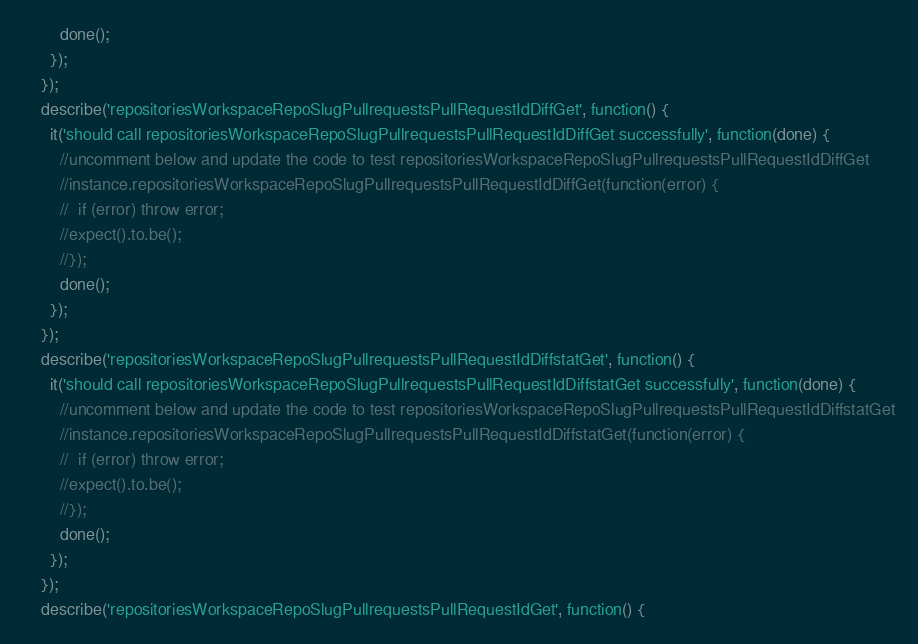<code> <loc_0><loc_0><loc_500><loc_500><_JavaScript_>        done();
      });
    });
    describe('repositoriesWorkspaceRepoSlugPullrequestsPullRequestIdDiffGet', function() {
      it('should call repositoriesWorkspaceRepoSlugPullrequestsPullRequestIdDiffGet successfully', function(done) {
        //uncomment below and update the code to test repositoriesWorkspaceRepoSlugPullrequestsPullRequestIdDiffGet
        //instance.repositoriesWorkspaceRepoSlugPullrequestsPullRequestIdDiffGet(function(error) {
        //  if (error) throw error;
        //expect().to.be();
        //});
        done();
      });
    });
    describe('repositoriesWorkspaceRepoSlugPullrequestsPullRequestIdDiffstatGet', function() {
      it('should call repositoriesWorkspaceRepoSlugPullrequestsPullRequestIdDiffstatGet successfully', function(done) {
        //uncomment below and update the code to test repositoriesWorkspaceRepoSlugPullrequestsPullRequestIdDiffstatGet
        //instance.repositoriesWorkspaceRepoSlugPullrequestsPullRequestIdDiffstatGet(function(error) {
        //  if (error) throw error;
        //expect().to.be();
        //});
        done();
      });
    });
    describe('repositoriesWorkspaceRepoSlugPullrequestsPullRequestIdGet', function() {</code> 